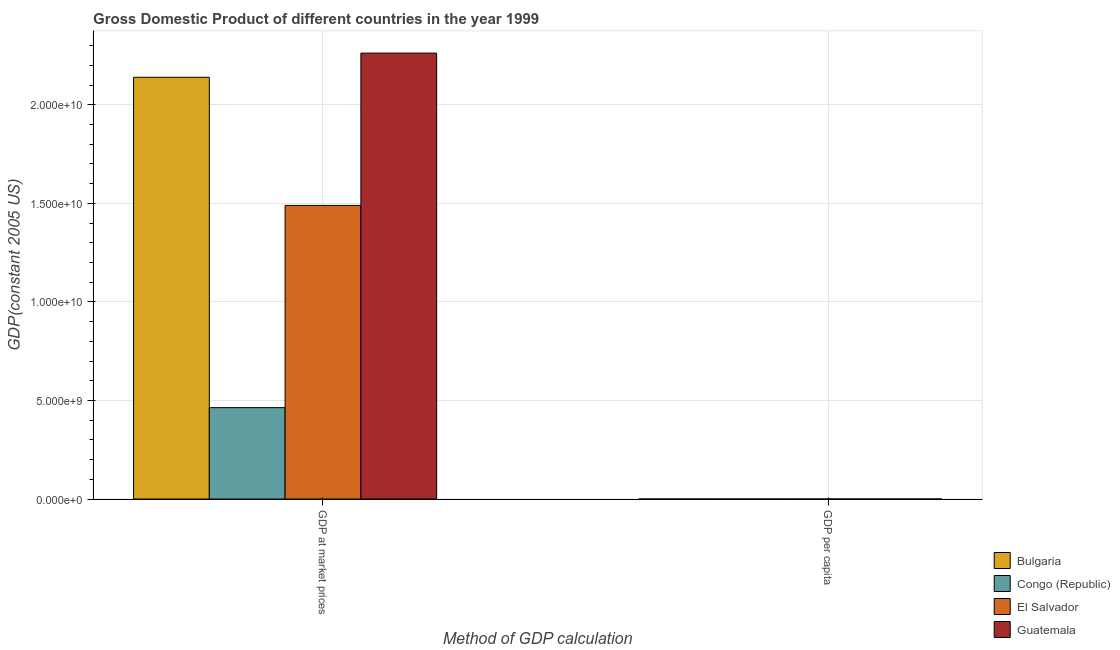How many groups of bars are there?
Make the answer very short. 2. Are the number of bars on each tick of the X-axis equal?
Provide a short and direct response. Yes. What is the label of the 1st group of bars from the left?
Make the answer very short. GDP at market prices. What is the gdp at market prices in Bulgaria?
Provide a short and direct response. 2.14e+1. Across all countries, what is the maximum gdp at market prices?
Make the answer very short. 2.26e+1. Across all countries, what is the minimum gdp at market prices?
Provide a short and direct response. 4.64e+09. In which country was the gdp at market prices maximum?
Your answer should be very brief. Guatemala. In which country was the gdp per capita minimum?
Your answer should be compact. Congo (Republic). What is the total gdp at market prices in the graph?
Your response must be concise. 6.36e+1. What is the difference between the gdp per capita in El Salvador and that in Bulgaria?
Keep it short and to the point. -26.92. What is the difference between the gdp per capita in Bulgaria and the gdp at market prices in El Salvador?
Your answer should be very brief. -1.49e+1. What is the average gdp per capita per country?
Offer a very short reply. 2174.6. What is the difference between the gdp at market prices and gdp per capita in El Salvador?
Your answer should be compact. 1.49e+1. In how many countries, is the gdp at market prices greater than 13000000000 US$?
Make the answer very short. 3. What is the ratio of the gdp at market prices in Congo (Republic) to that in El Salvador?
Keep it short and to the point. 0.31. What does the 1st bar from the left in GDP at market prices represents?
Your answer should be very brief. Bulgaria. What does the 1st bar from the right in GDP at market prices represents?
Your answer should be very brief. Guatemala. Are all the bars in the graph horizontal?
Your response must be concise. No. What is the difference between two consecutive major ticks on the Y-axis?
Offer a terse response. 5.00e+09. Are the values on the major ticks of Y-axis written in scientific E-notation?
Ensure brevity in your answer.  Yes. Does the graph contain grids?
Your response must be concise. Yes. How are the legend labels stacked?
Ensure brevity in your answer.  Vertical. What is the title of the graph?
Offer a very short reply. Gross Domestic Product of different countries in the year 1999. What is the label or title of the X-axis?
Keep it short and to the point. Method of GDP calculation. What is the label or title of the Y-axis?
Provide a short and direct response. GDP(constant 2005 US). What is the GDP(constant 2005 US) in Bulgaria in GDP at market prices?
Offer a very short reply. 2.14e+1. What is the GDP(constant 2005 US) in Congo (Republic) in GDP at market prices?
Provide a succinct answer. 4.64e+09. What is the GDP(constant 2005 US) of El Salvador in GDP at market prices?
Offer a terse response. 1.49e+1. What is the GDP(constant 2005 US) in Guatemala in GDP at market prices?
Your answer should be very brief. 2.26e+1. What is the GDP(constant 2005 US) of Bulgaria in GDP per capita?
Ensure brevity in your answer.  2606.43. What is the GDP(constant 2005 US) of Congo (Republic) in GDP per capita?
Keep it short and to the point. 1529.32. What is the GDP(constant 2005 US) of El Salvador in GDP per capita?
Your answer should be compact. 2579.51. What is the GDP(constant 2005 US) in Guatemala in GDP per capita?
Offer a very short reply. 1983.16. Across all Method of GDP calculation, what is the maximum GDP(constant 2005 US) in Bulgaria?
Make the answer very short. 2.14e+1. Across all Method of GDP calculation, what is the maximum GDP(constant 2005 US) of Congo (Republic)?
Your answer should be compact. 4.64e+09. Across all Method of GDP calculation, what is the maximum GDP(constant 2005 US) in El Salvador?
Keep it short and to the point. 1.49e+1. Across all Method of GDP calculation, what is the maximum GDP(constant 2005 US) in Guatemala?
Provide a short and direct response. 2.26e+1. Across all Method of GDP calculation, what is the minimum GDP(constant 2005 US) in Bulgaria?
Provide a succinct answer. 2606.43. Across all Method of GDP calculation, what is the minimum GDP(constant 2005 US) of Congo (Republic)?
Your response must be concise. 1529.32. Across all Method of GDP calculation, what is the minimum GDP(constant 2005 US) in El Salvador?
Give a very brief answer. 2579.51. Across all Method of GDP calculation, what is the minimum GDP(constant 2005 US) in Guatemala?
Give a very brief answer. 1983.16. What is the total GDP(constant 2005 US) in Bulgaria in the graph?
Your answer should be very brief. 2.14e+1. What is the total GDP(constant 2005 US) in Congo (Republic) in the graph?
Keep it short and to the point. 4.64e+09. What is the total GDP(constant 2005 US) of El Salvador in the graph?
Offer a very short reply. 1.49e+1. What is the total GDP(constant 2005 US) in Guatemala in the graph?
Give a very brief answer. 2.26e+1. What is the difference between the GDP(constant 2005 US) in Bulgaria in GDP at market prices and that in GDP per capita?
Offer a terse response. 2.14e+1. What is the difference between the GDP(constant 2005 US) in Congo (Republic) in GDP at market prices and that in GDP per capita?
Ensure brevity in your answer.  4.64e+09. What is the difference between the GDP(constant 2005 US) of El Salvador in GDP at market prices and that in GDP per capita?
Your answer should be very brief. 1.49e+1. What is the difference between the GDP(constant 2005 US) of Guatemala in GDP at market prices and that in GDP per capita?
Offer a very short reply. 2.26e+1. What is the difference between the GDP(constant 2005 US) of Bulgaria in GDP at market prices and the GDP(constant 2005 US) of Congo (Republic) in GDP per capita?
Make the answer very short. 2.14e+1. What is the difference between the GDP(constant 2005 US) in Bulgaria in GDP at market prices and the GDP(constant 2005 US) in El Salvador in GDP per capita?
Ensure brevity in your answer.  2.14e+1. What is the difference between the GDP(constant 2005 US) of Bulgaria in GDP at market prices and the GDP(constant 2005 US) of Guatemala in GDP per capita?
Provide a short and direct response. 2.14e+1. What is the difference between the GDP(constant 2005 US) of Congo (Republic) in GDP at market prices and the GDP(constant 2005 US) of El Salvador in GDP per capita?
Provide a short and direct response. 4.64e+09. What is the difference between the GDP(constant 2005 US) in Congo (Republic) in GDP at market prices and the GDP(constant 2005 US) in Guatemala in GDP per capita?
Your answer should be very brief. 4.64e+09. What is the difference between the GDP(constant 2005 US) in El Salvador in GDP at market prices and the GDP(constant 2005 US) in Guatemala in GDP per capita?
Make the answer very short. 1.49e+1. What is the average GDP(constant 2005 US) of Bulgaria per Method of GDP calculation?
Your answer should be very brief. 1.07e+1. What is the average GDP(constant 2005 US) of Congo (Republic) per Method of GDP calculation?
Offer a very short reply. 2.32e+09. What is the average GDP(constant 2005 US) in El Salvador per Method of GDP calculation?
Ensure brevity in your answer.  7.45e+09. What is the average GDP(constant 2005 US) in Guatemala per Method of GDP calculation?
Provide a succinct answer. 1.13e+1. What is the difference between the GDP(constant 2005 US) of Bulgaria and GDP(constant 2005 US) of Congo (Republic) in GDP at market prices?
Make the answer very short. 1.68e+1. What is the difference between the GDP(constant 2005 US) in Bulgaria and GDP(constant 2005 US) in El Salvador in GDP at market prices?
Offer a terse response. 6.50e+09. What is the difference between the GDP(constant 2005 US) of Bulgaria and GDP(constant 2005 US) of Guatemala in GDP at market prices?
Keep it short and to the point. -1.23e+09. What is the difference between the GDP(constant 2005 US) in Congo (Republic) and GDP(constant 2005 US) in El Salvador in GDP at market prices?
Provide a short and direct response. -1.03e+1. What is the difference between the GDP(constant 2005 US) in Congo (Republic) and GDP(constant 2005 US) in Guatemala in GDP at market prices?
Your answer should be compact. -1.80e+1. What is the difference between the GDP(constant 2005 US) of El Salvador and GDP(constant 2005 US) of Guatemala in GDP at market prices?
Give a very brief answer. -7.73e+09. What is the difference between the GDP(constant 2005 US) in Bulgaria and GDP(constant 2005 US) in Congo (Republic) in GDP per capita?
Your response must be concise. 1077.11. What is the difference between the GDP(constant 2005 US) of Bulgaria and GDP(constant 2005 US) of El Salvador in GDP per capita?
Keep it short and to the point. 26.92. What is the difference between the GDP(constant 2005 US) of Bulgaria and GDP(constant 2005 US) of Guatemala in GDP per capita?
Make the answer very short. 623.27. What is the difference between the GDP(constant 2005 US) in Congo (Republic) and GDP(constant 2005 US) in El Salvador in GDP per capita?
Ensure brevity in your answer.  -1050.19. What is the difference between the GDP(constant 2005 US) of Congo (Republic) and GDP(constant 2005 US) of Guatemala in GDP per capita?
Make the answer very short. -453.84. What is the difference between the GDP(constant 2005 US) of El Salvador and GDP(constant 2005 US) of Guatemala in GDP per capita?
Offer a terse response. 596.34. What is the ratio of the GDP(constant 2005 US) in Bulgaria in GDP at market prices to that in GDP per capita?
Your response must be concise. 8.21e+06. What is the ratio of the GDP(constant 2005 US) in Congo (Republic) in GDP at market prices to that in GDP per capita?
Your answer should be compact. 3.03e+06. What is the ratio of the GDP(constant 2005 US) of El Salvador in GDP at market prices to that in GDP per capita?
Provide a succinct answer. 5.78e+06. What is the ratio of the GDP(constant 2005 US) of Guatemala in GDP at market prices to that in GDP per capita?
Your answer should be compact. 1.14e+07. What is the difference between the highest and the second highest GDP(constant 2005 US) in Bulgaria?
Your answer should be very brief. 2.14e+1. What is the difference between the highest and the second highest GDP(constant 2005 US) in Congo (Republic)?
Provide a succinct answer. 4.64e+09. What is the difference between the highest and the second highest GDP(constant 2005 US) in El Salvador?
Make the answer very short. 1.49e+1. What is the difference between the highest and the second highest GDP(constant 2005 US) in Guatemala?
Your response must be concise. 2.26e+1. What is the difference between the highest and the lowest GDP(constant 2005 US) of Bulgaria?
Your response must be concise. 2.14e+1. What is the difference between the highest and the lowest GDP(constant 2005 US) of Congo (Republic)?
Provide a succinct answer. 4.64e+09. What is the difference between the highest and the lowest GDP(constant 2005 US) in El Salvador?
Your answer should be very brief. 1.49e+1. What is the difference between the highest and the lowest GDP(constant 2005 US) of Guatemala?
Ensure brevity in your answer.  2.26e+1. 